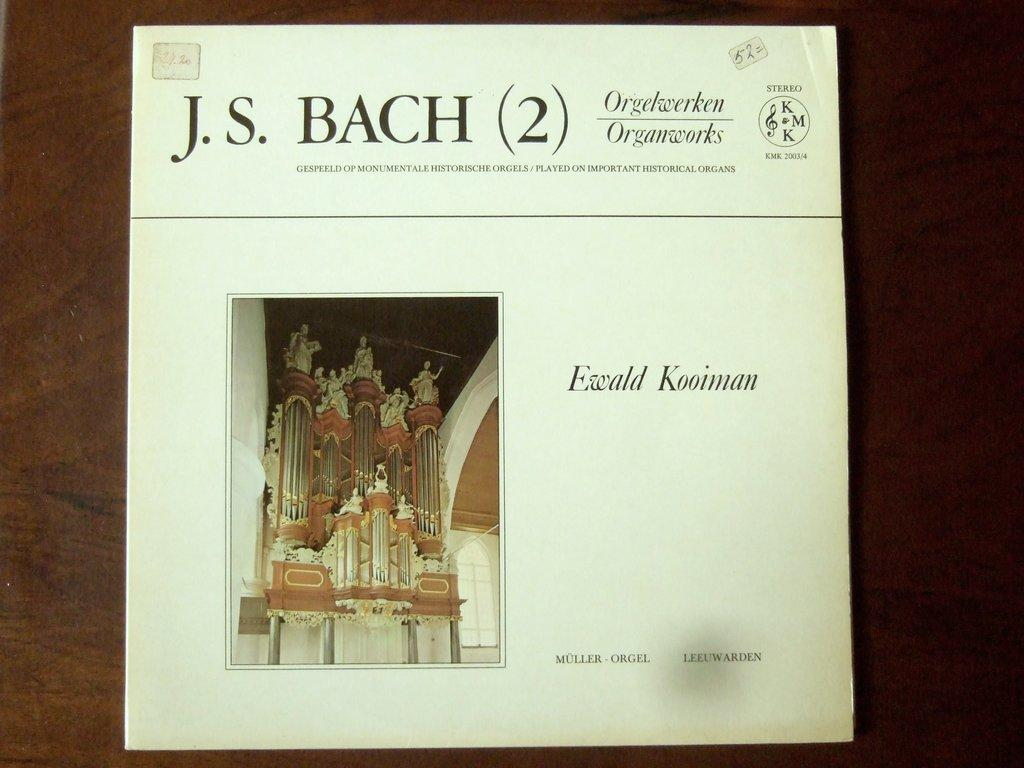<image>
Write a terse but informative summary of the picture. An album from J.S. Bach has a photo of an organ on the front. 